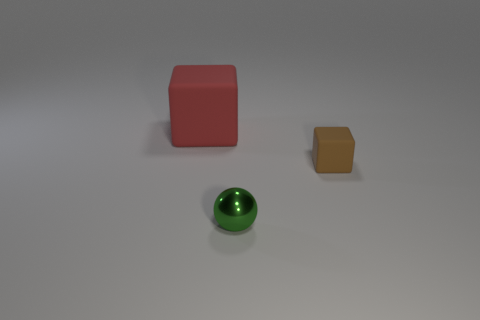Is there anything else that has the same material as the small sphere?
Offer a terse response. No. Is there any other thing that has the same shape as the tiny green shiny object?
Provide a succinct answer. No. How many metallic things are red cubes or tiny brown objects?
Your response must be concise. 0. There is a brown rubber block; what number of objects are on the left side of it?
Keep it short and to the point. 2. Are there any blocks that have the same size as the ball?
Offer a terse response. Yes. Is there anything else that has the same size as the red block?
Ensure brevity in your answer.  No. How many small matte cubes are the same color as the small shiny ball?
Ensure brevity in your answer.  0. How many things are either tiny brown rubber cubes or blocks behind the small brown rubber cube?
Ensure brevity in your answer.  2. What is the size of the cube that is behind the tiny thing to the right of the small shiny thing?
Provide a succinct answer. Large. Are there an equal number of red objects that are in front of the big red block and red things that are in front of the tiny green ball?
Your response must be concise. Yes. 